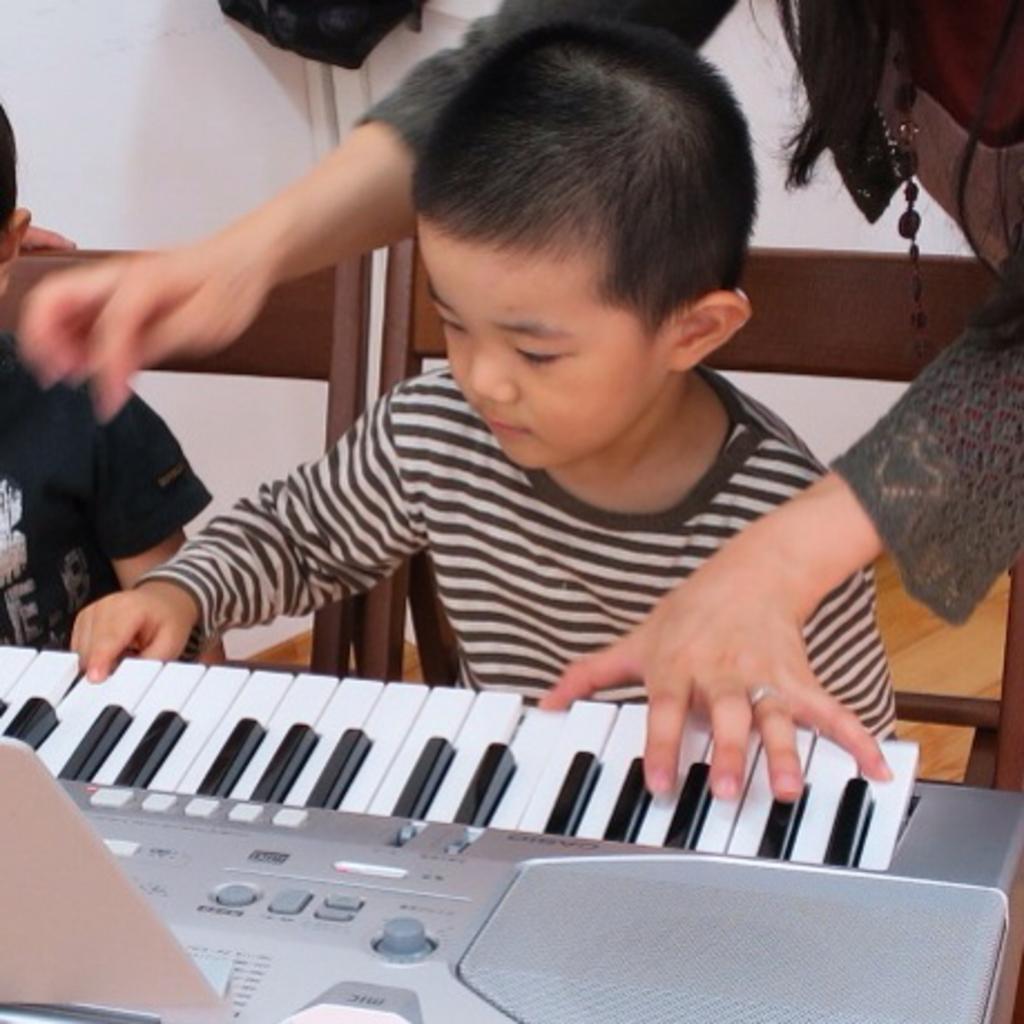In one or two sentences, can you explain what this image depicts? Here we can see a boy is playing the piano, and at back a woman is standing. 